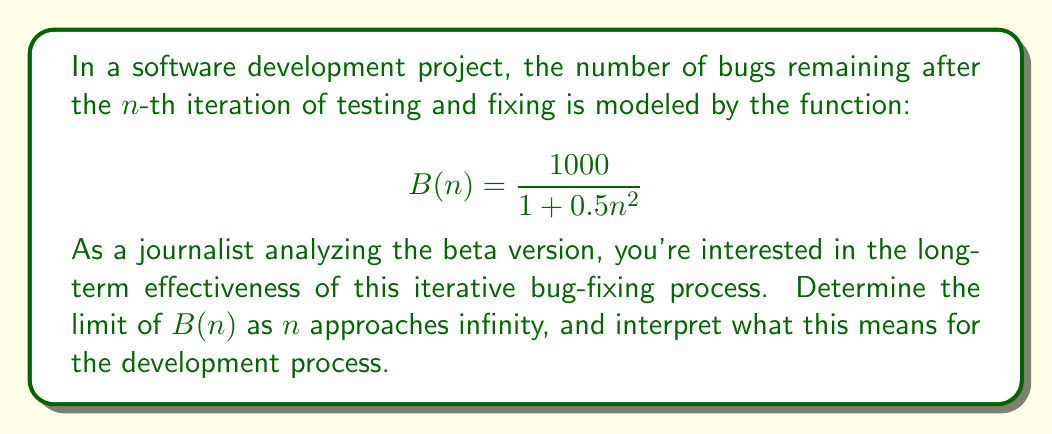Could you help me with this problem? To solve this problem, we'll use limit theory to analyze the convergence of the given function as n approaches infinity.

1) First, let's examine the function:

   $$B(n) = \frac{1000}{1 + 0.5n^2}$$

2) To find the limit as n approaches infinity, we need to consider what happens to the denominator:

   $$\lim_{n \to \infty} B(n) = \lim_{n \to \infty} \frac{1000}{1 + 0.5n^2}$$

3) As n grows larger, the term $0.5n^2$ in the denominator becomes much larger than 1. So, for very large n, we can approximate:

   $$\lim_{n \to \infty} \frac{1000}{1 + 0.5n^2} \approx \lim_{n \to \infty} \frac{1000}{0.5n^2}$$

4) Simplify:

   $$\lim_{n \to \infty} \frac{2000}{n^2}$$

5) As n approaches infinity, $n^2$ grows much faster than 2000, so this fraction approaches 0:

   $$\lim_{n \to \infty} \frac{2000}{n^2} = 0$$

6) Interpretation: This limit of 0 means that as the number of iterations (n) increases indefinitely, the number of remaining bugs approaches 0. In other words, the iterative bug-fixing process is theoretically capable of eliminating all bugs if continued indefinitely.

However, it's important to note that in practice, reaching exactly zero bugs may not be feasible due to various real-world constraints and the potential introduction of new bugs during fixes.
Answer: The limit of B(n) as n approaches infinity is 0.

$$\lim_{n \to \infty} B(n) = 0$$

This indicates that the iterative bug-fixing process is theoretically capable of eliminating all bugs if continued indefinitely. 